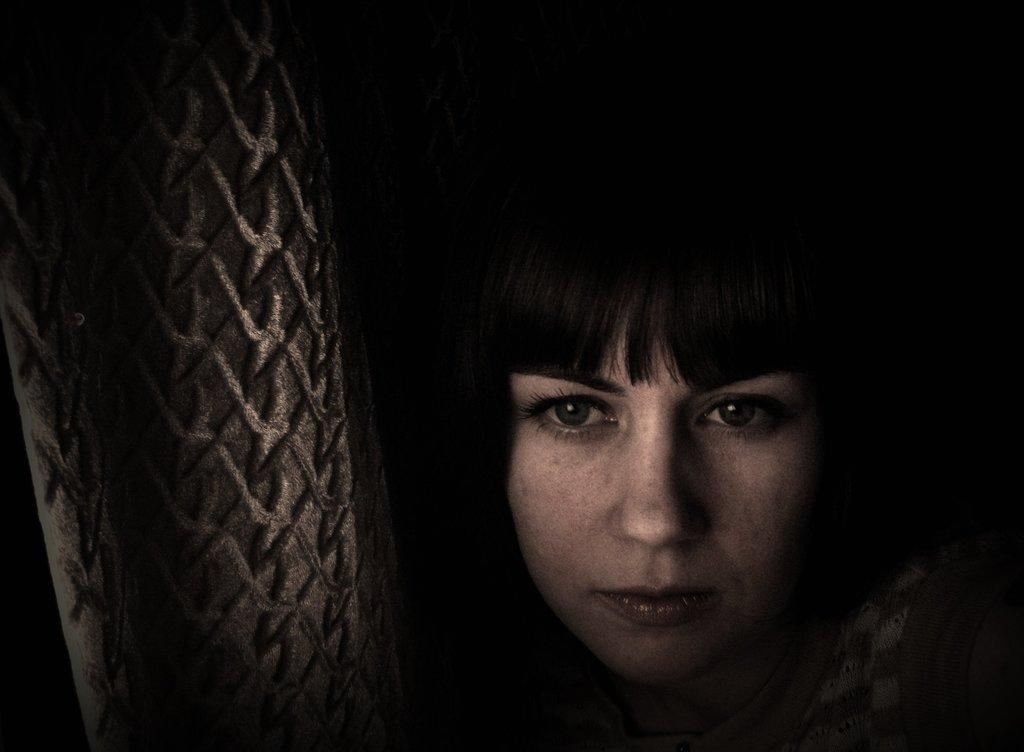What is the main subject of the image? The main subject of the image is a woman's face. What type of image is it? The image appears to be of an object, specifically a woman's face. What can be observed about the background of the image? The background of the image is dark. How many cars are visible in the image? There are no cars present in the image; it features a woman's face. What is the limit of the addition in the image? There is no addition or mathematical operation present in the image; it is a photograph of a woman's face. 